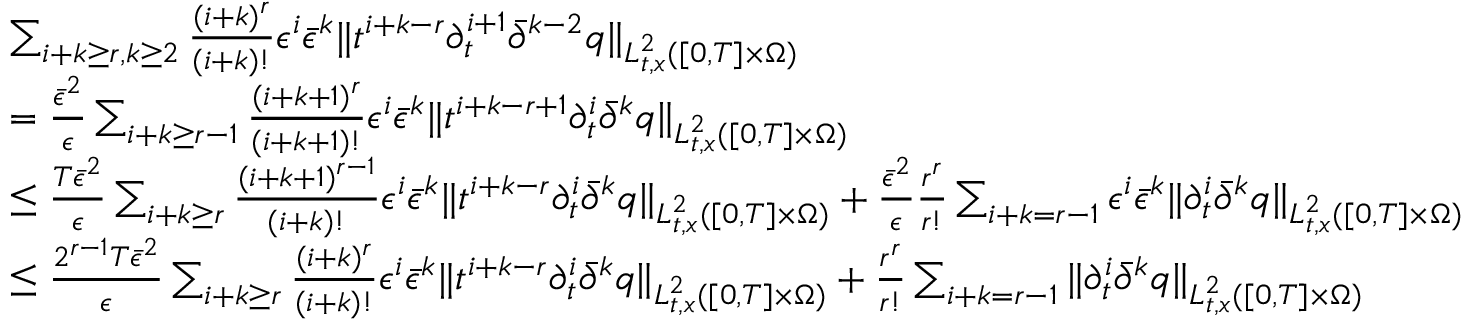<formula> <loc_0><loc_0><loc_500><loc_500>\begin{array} { r l } & { \sum _ { i + k \geq r , k \geq 2 } \frac { ( i + k ) ^ { r } } { ( i + k ) ! } \epsilon ^ { i } \bar { \epsilon } ^ { k } \| t ^ { i + k - r } \partial _ { t } ^ { i + 1 } \bar { \partial } ^ { k - 2 } q \| _ { L _ { t , x } ^ { 2 } ( [ 0 , T ] \times \Omega ) } } \\ & { = \frac { \bar { \epsilon } ^ { 2 } } { \epsilon } \sum _ { i + k \geq r - 1 } \frac { ( i + k + 1 ) ^ { r } } { ( i + k + 1 ) ! } \epsilon ^ { i } \bar { \epsilon } ^ { k } \| t ^ { i + k - r + 1 } \partial _ { t } ^ { i } \bar { \partial } ^ { k } q \| _ { L _ { t , x } ^ { 2 } ( [ 0 , T ] \times \Omega ) } } \\ & { \leq \frac { T \bar { \epsilon } ^ { 2 } } { \epsilon } \sum _ { i + k \geq r } \frac { ( i + k + 1 ) ^ { r - 1 } } { ( i + k ) ! } \epsilon ^ { i } \bar { \epsilon } ^ { k } \| t ^ { i + k - r } \partial _ { t } ^ { i } \bar { \partial } ^ { k } q \| _ { L _ { t , x } ^ { 2 } ( [ 0 , T ] \times \Omega ) } + \frac { \bar { \epsilon } ^ { 2 } } { \epsilon } \frac { r ^ { r } } { r ! } \sum _ { i + k = r - 1 } \epsilon ^ { i } \bar { \epsilon } ^ { k } \| \partial _ { t } ^ { i } \bar { \partial } ^ { k } q \| _ { L _ { t , x } ^ { 2 } ( [ 0 , T ] \times \Omega ) } } \\ & { \leq \frac { 2 ^ { r - 1 } T \bar { \epsilon } ^ { 2 } } { \epsilon } \sum _ { i + k \geq r } \frac { ( i + k ) ^ { r } } { ( i + k ) ! } \epsilon ^ { i } \bar { \epsilon } ^ { k } \| t ^ { i + k - r } \partial _ { t } ^ { i } \bar { \partial } ^ { k } q \| _ { L _ { t , x } ^ { 2 } ( [ 0 , T ] \times \Omega ) } + \frac { r ^ { r } } { r ! } \sum _ { i + k = r - 1 } \| \partial _ { t } ^ { i } \bar { \partial } ^ { k } q \| _ { L _ { t , x } ^ { 2 } ( [ 0 , T ] \times \Omega ) } } \end{array}</formula> 